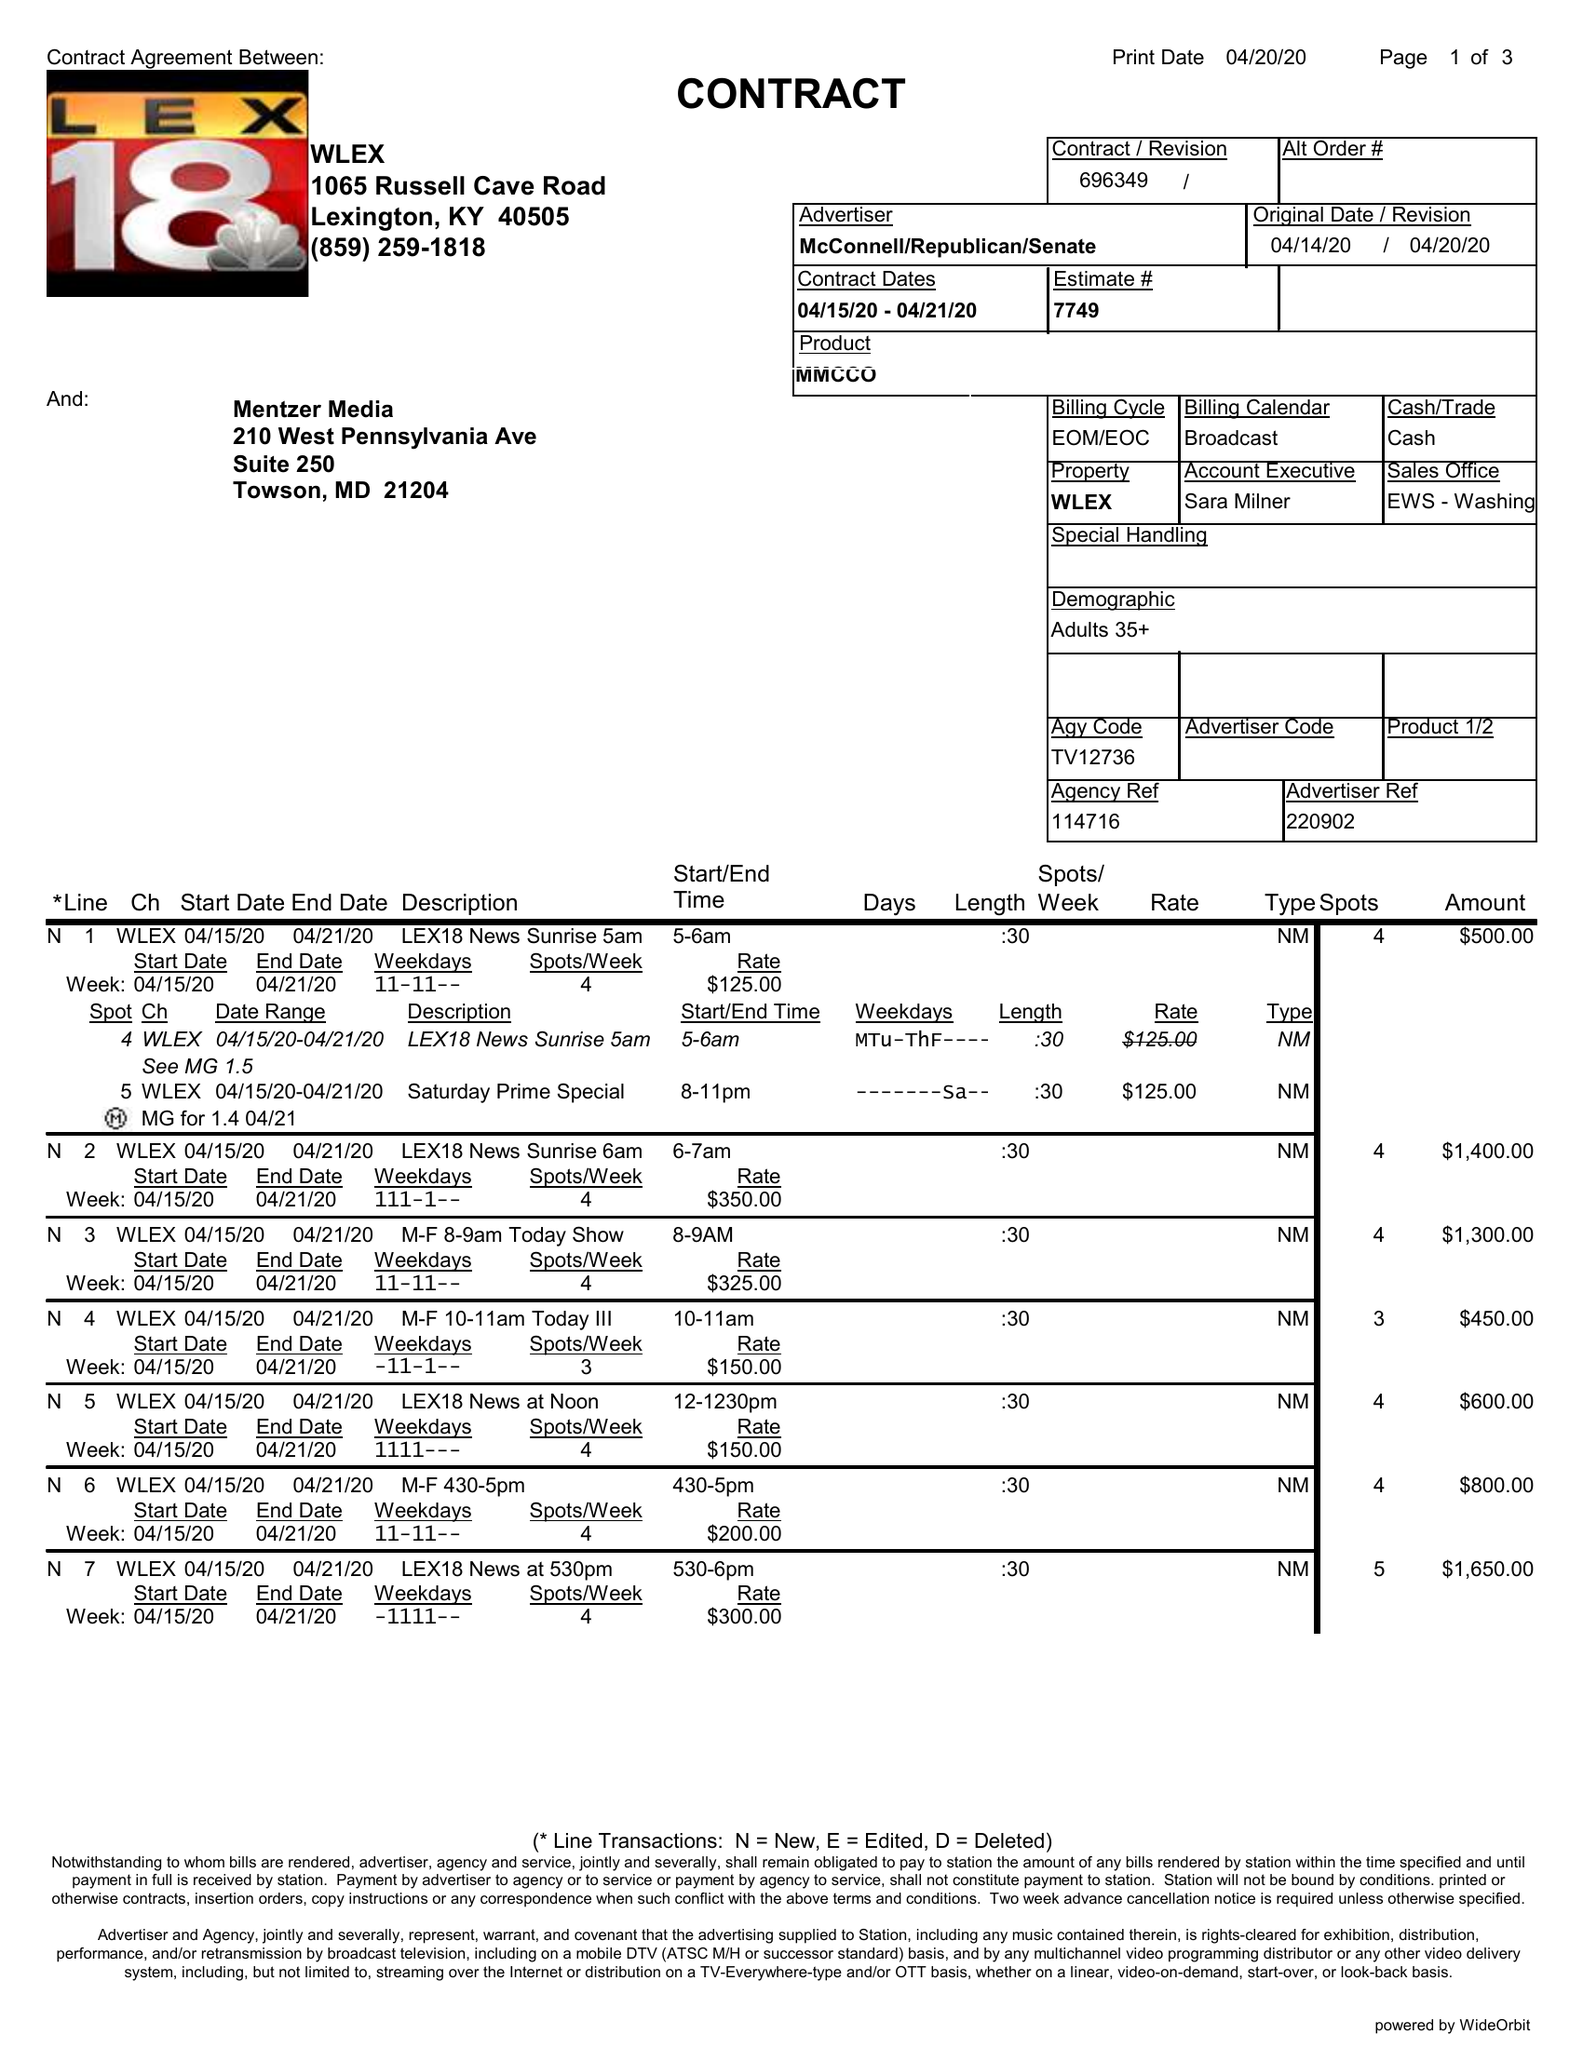What is the value for the contract_num?
Answer the question using a single word or phrase. 696349 